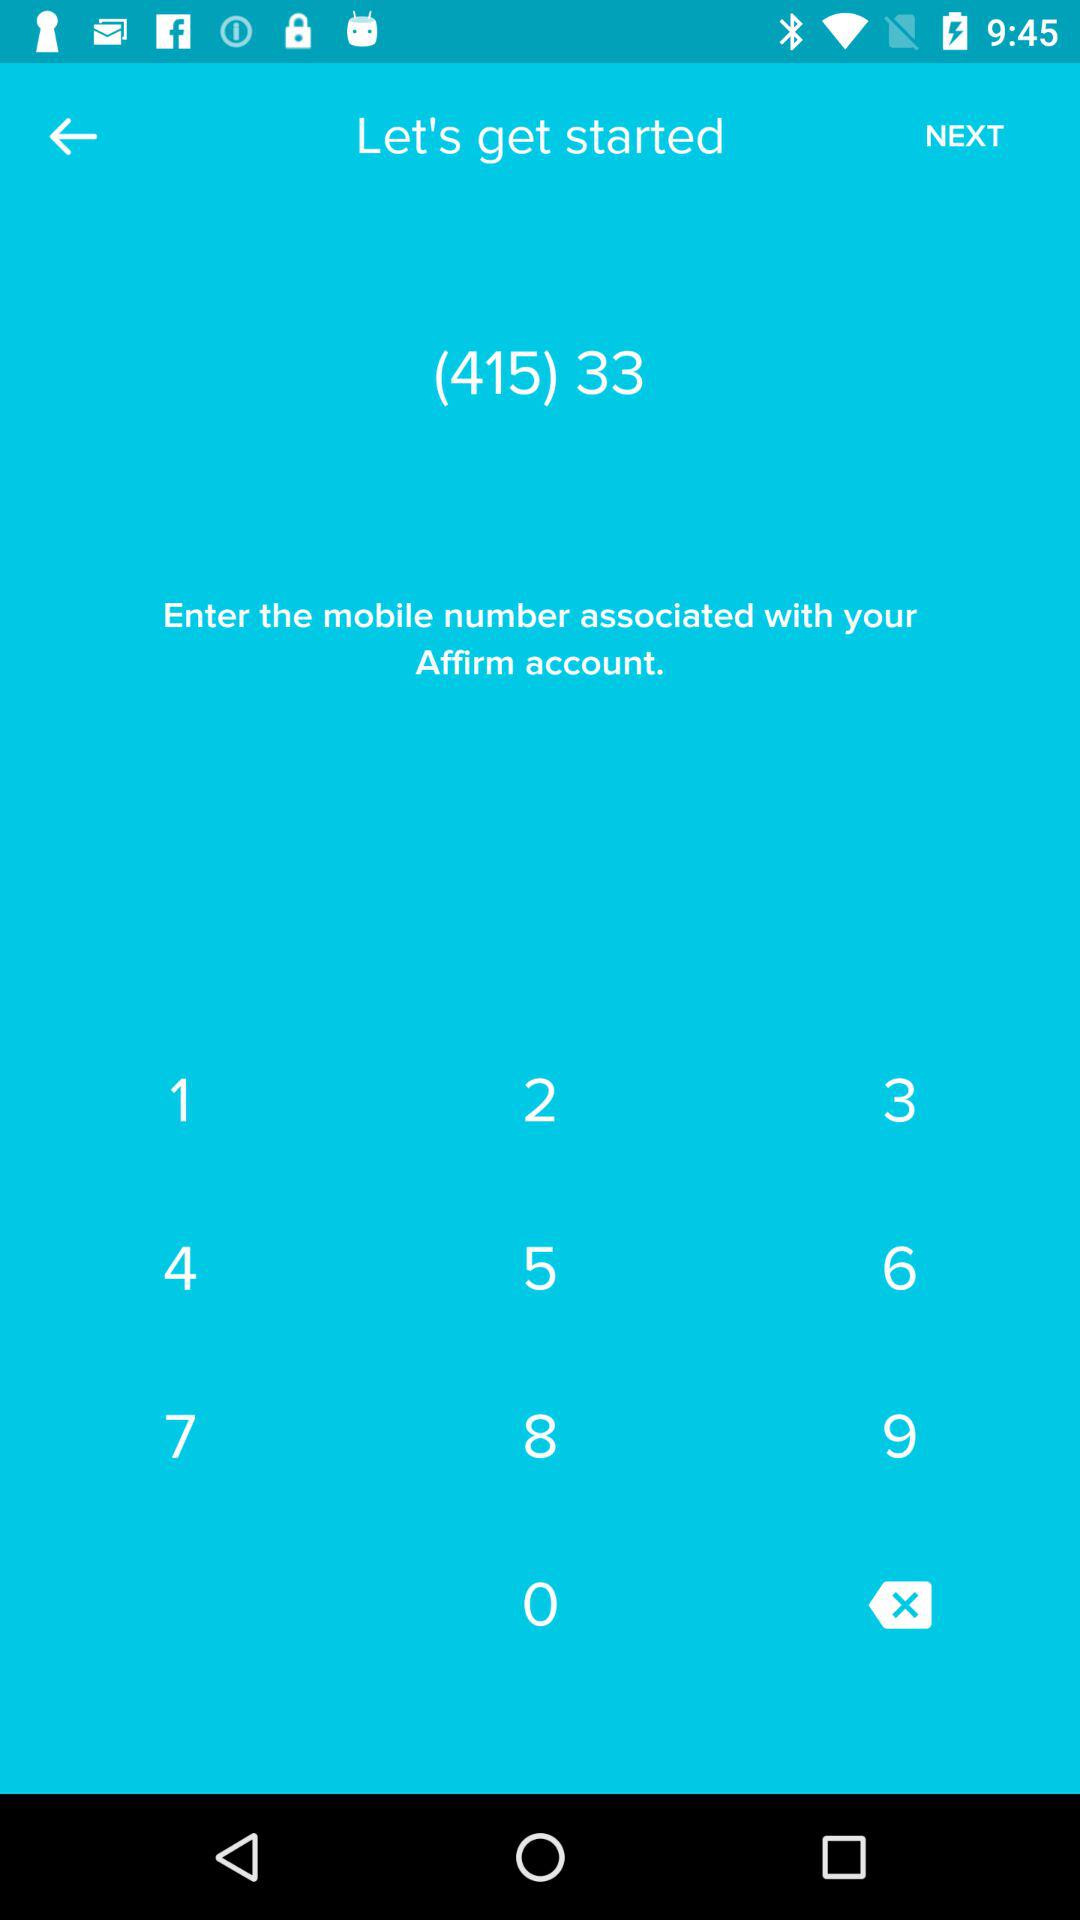What is the entered number on the screen? The entered number on the screen is (415) 33. 